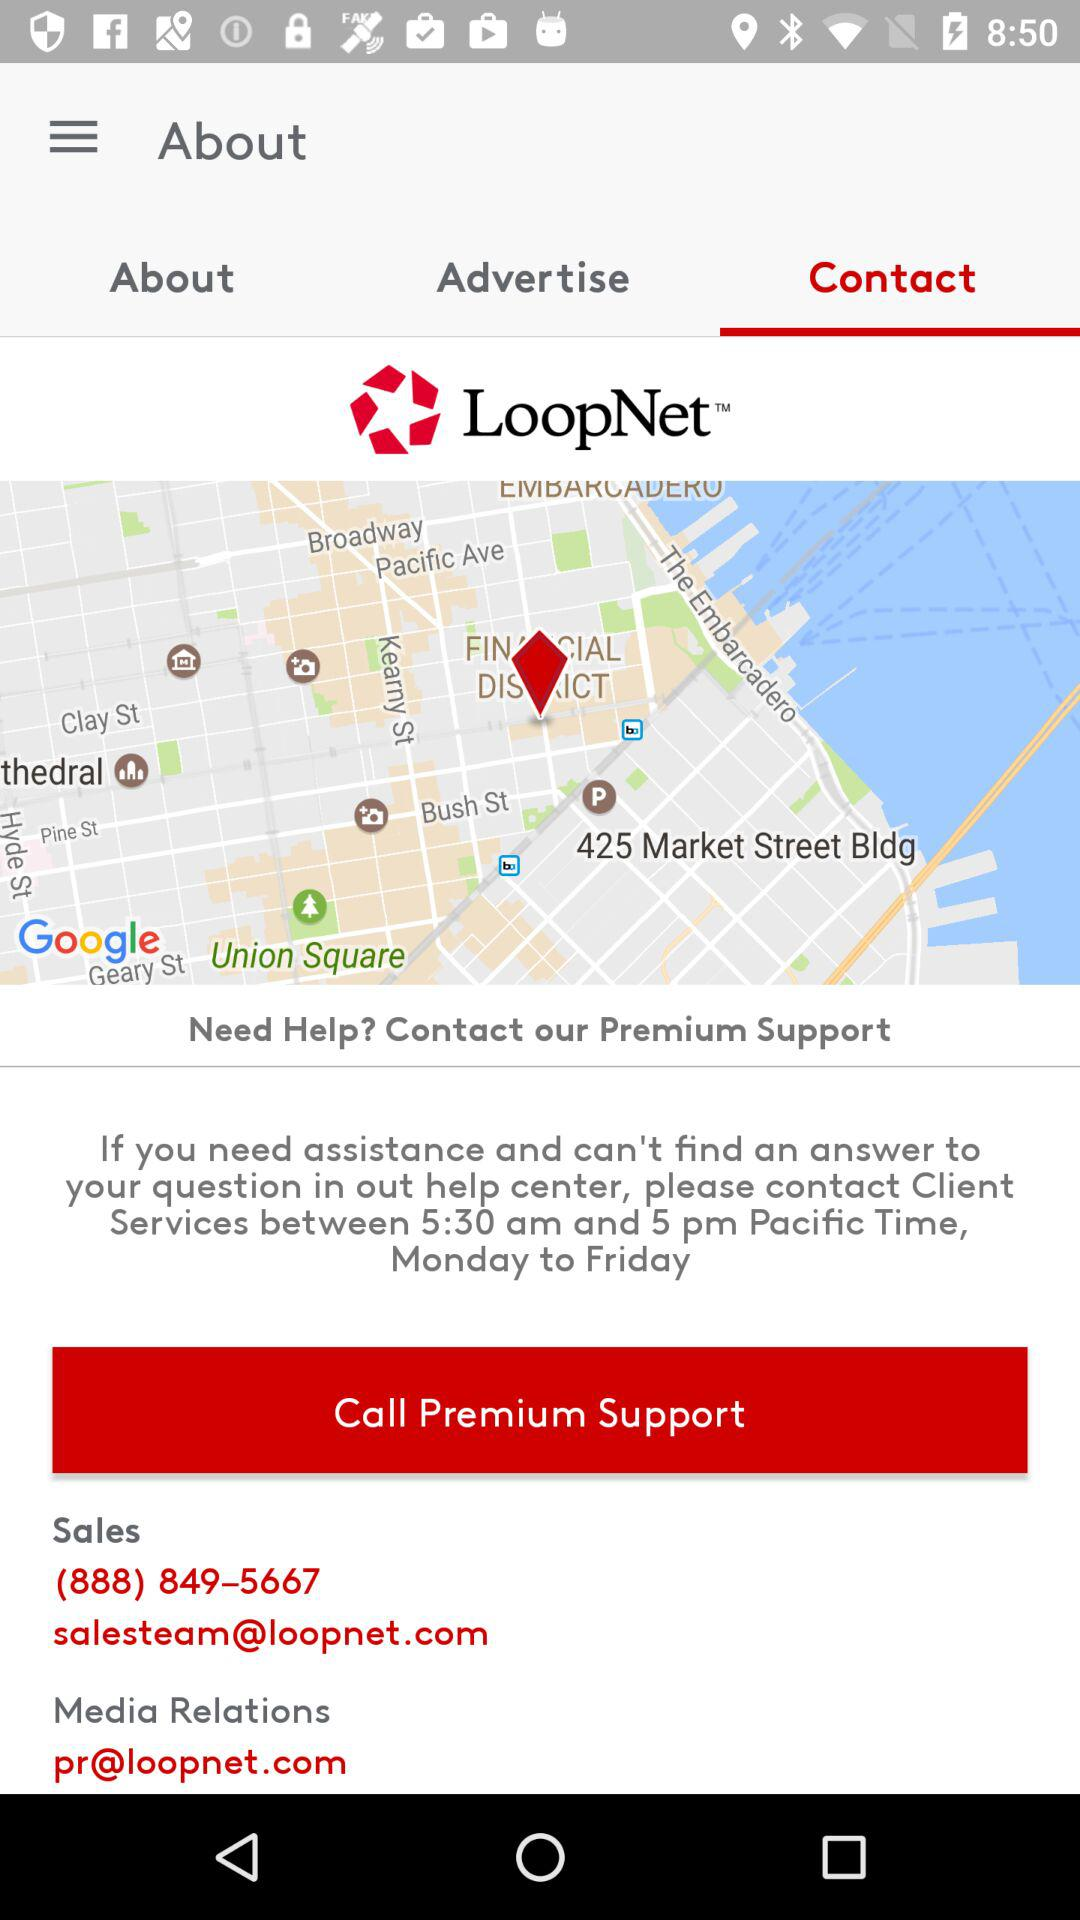What are the timings for availing the services? The timings for availing the services are between 5:30 a.m. and 5 p.m. Pacific Time, Monday to Friday. 